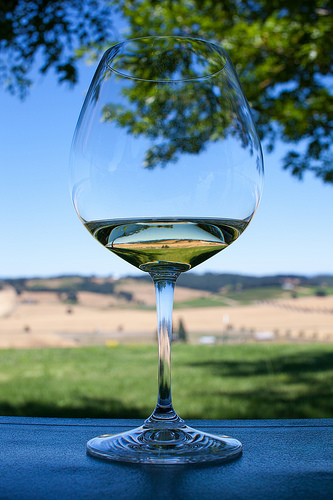<image>
Is the glass next to the sky? No. The glass is not positioned next to the sky. They are located in different areas of the scene. Is the liquid next to the mountain? No. The liquid is not positioned next to the mountain. They are located in different areas of the scene. 